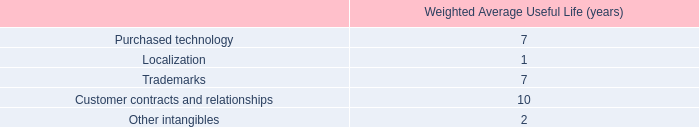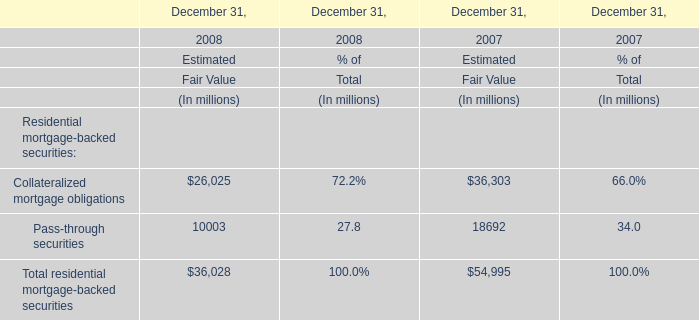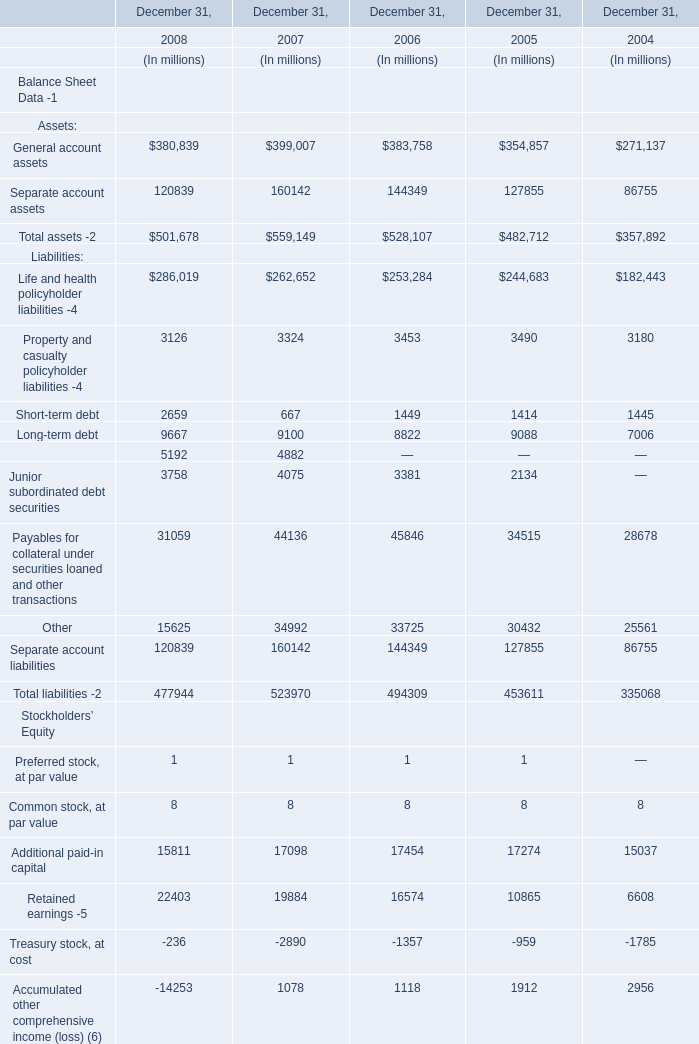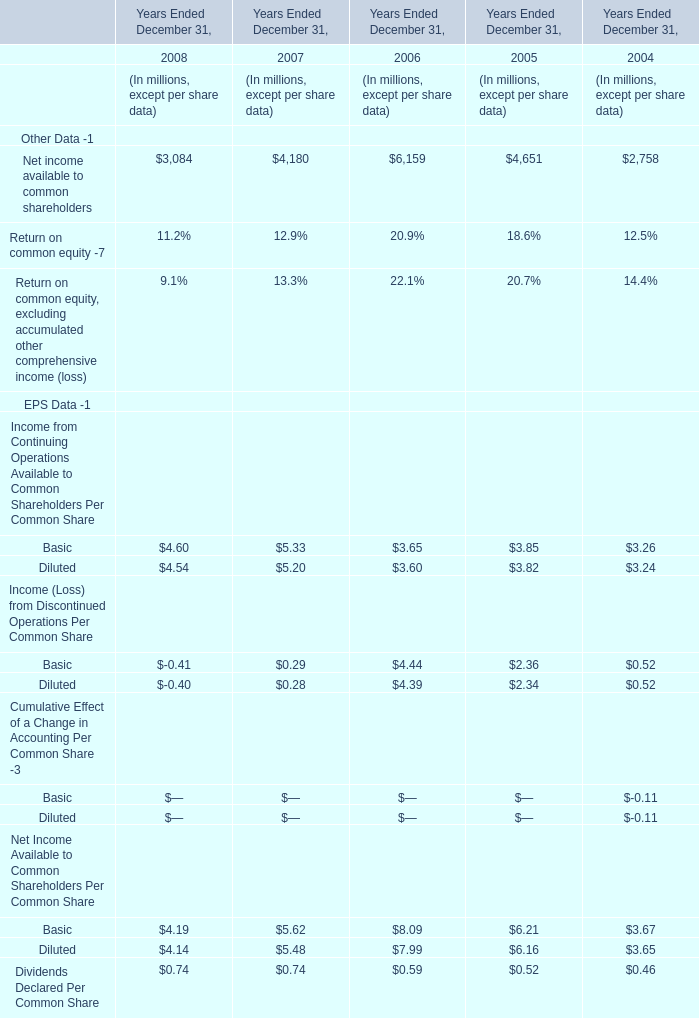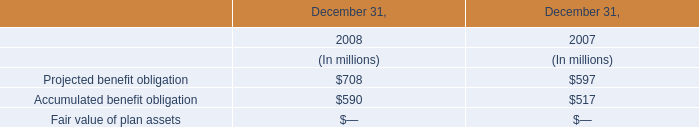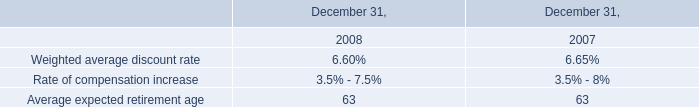In the year with largest amount of General account assets , what's the sum of Assets:? (in million) 
Computations: (399007 + 160142)
Answer: 559149.0. 